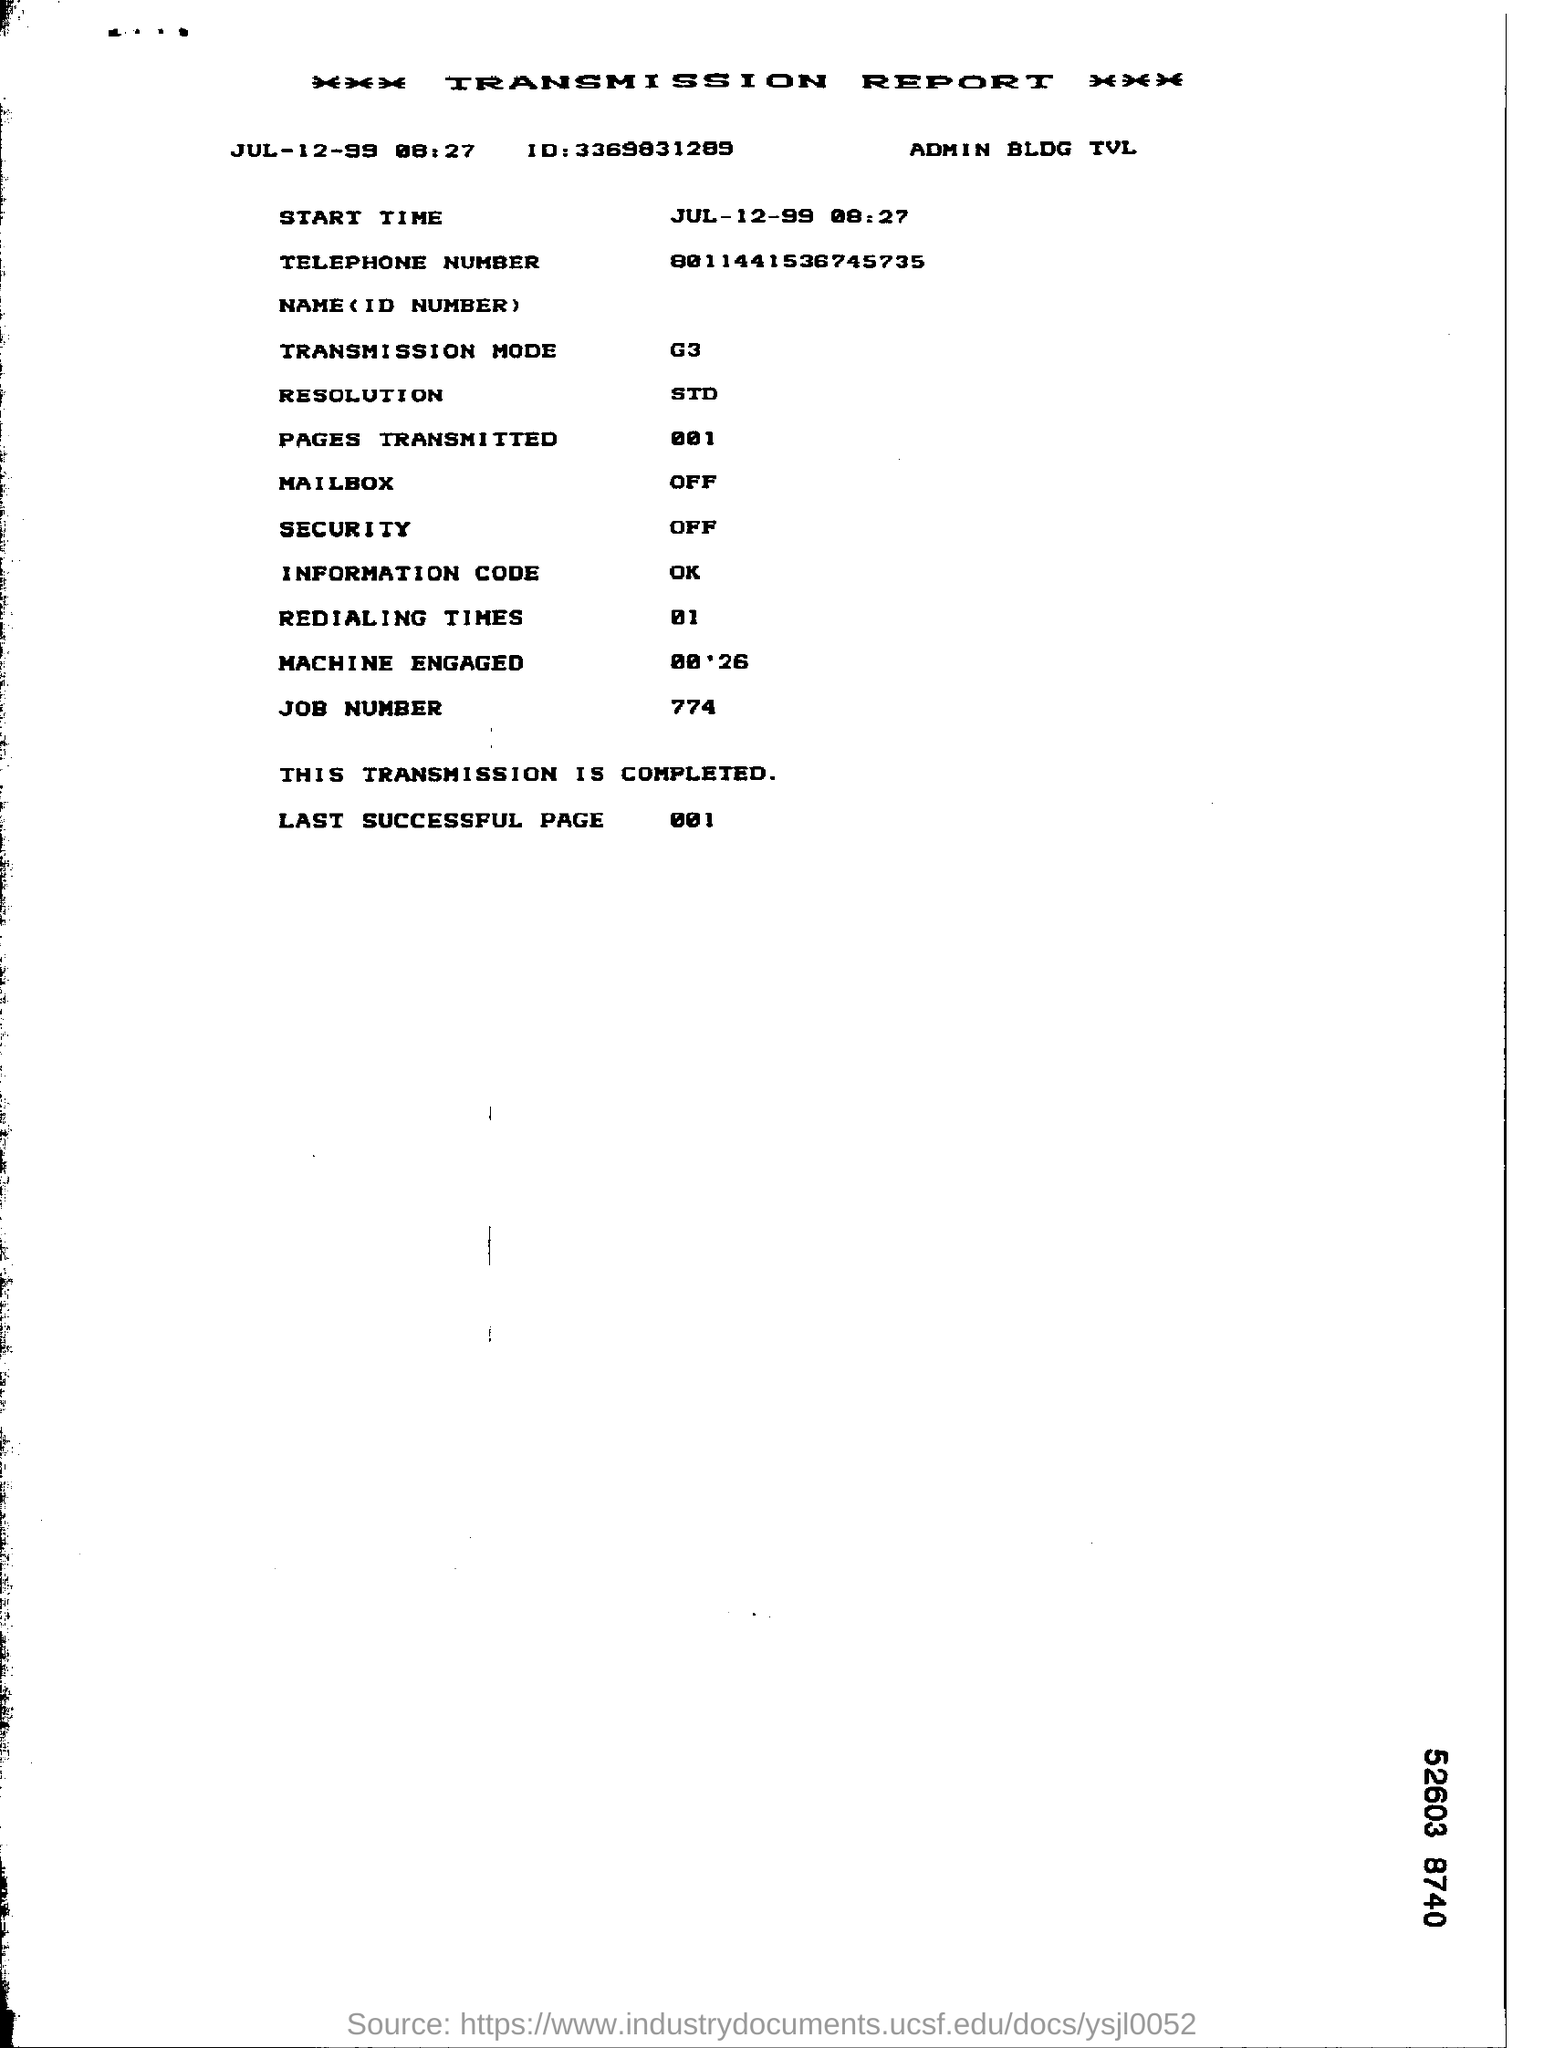Highlight a few significant elements in this photo. The date mentioned in the transmission report is July 12, 1999. The job number mentioned in the report is 774. The transmission mode mentioned in the report is G.3. The status of the mailbox mentioned in the transmission report is "off". The security status in the transmission report is currently OFF. 